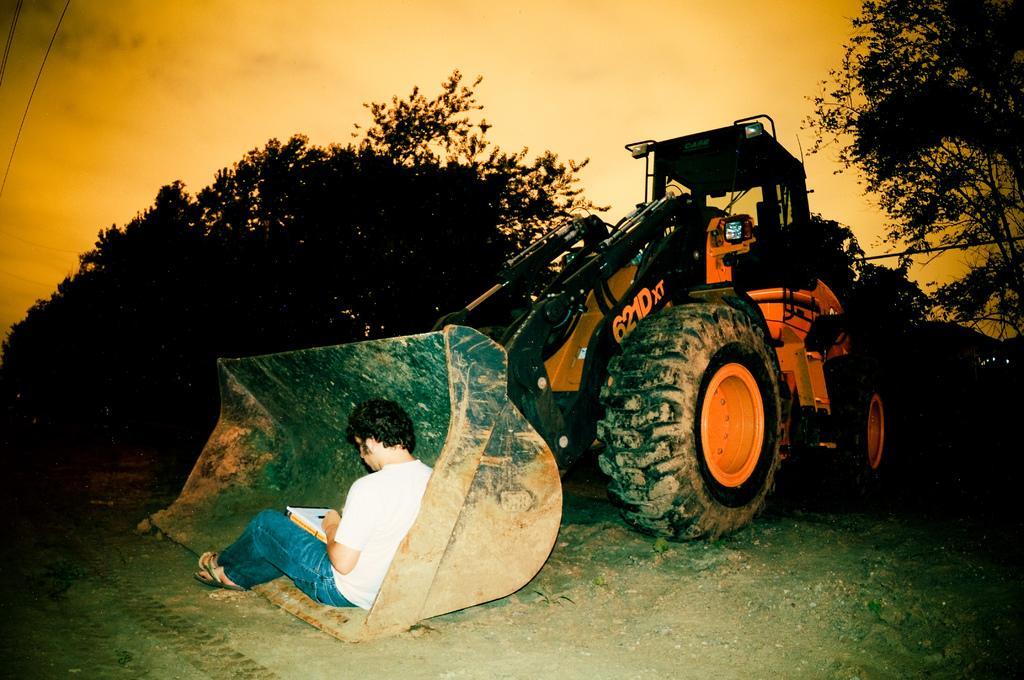In one or two sentences, can you explain what this image depicts? In this picture I can see there is a tractor and there is a person sitting here at left and he is wearing a white shirt, jeans and there are few trees in the backdrop and the sky is clear. 